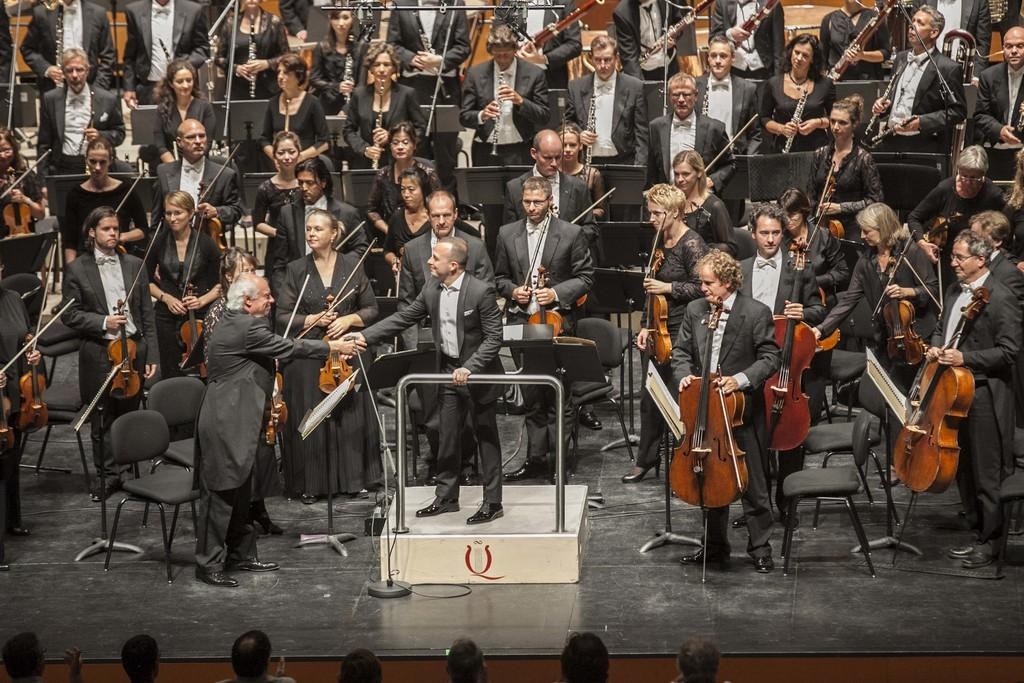What are the people in the image doing? The people in the image are standing and playing musical instruments. Can you describe the man's position in the image? The man is standing on a subject, which is likely a stage or platform. What is the man doing with another person in the image? The man is shaking hands with another person. What type of food is the man holding in the image? There is no food present in the image; the man is shaking hands with another person. 